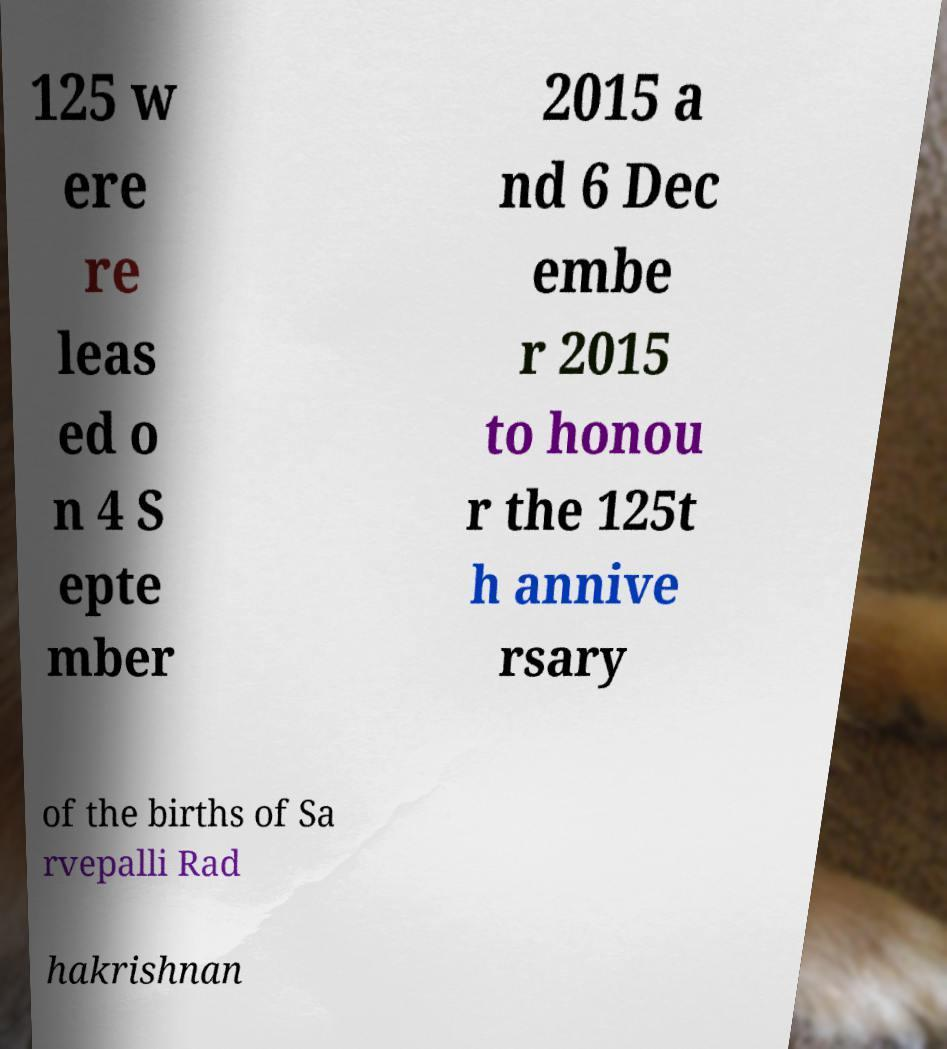Please identify and transcribe the text found in this image. 125 w ere re leas ed o n 4 S epte mber 2015 a nd 6 Dec embe r 2015 to honou r the 125t h annive rsary of the births of Sa rvepalli Rad hakrishnan 